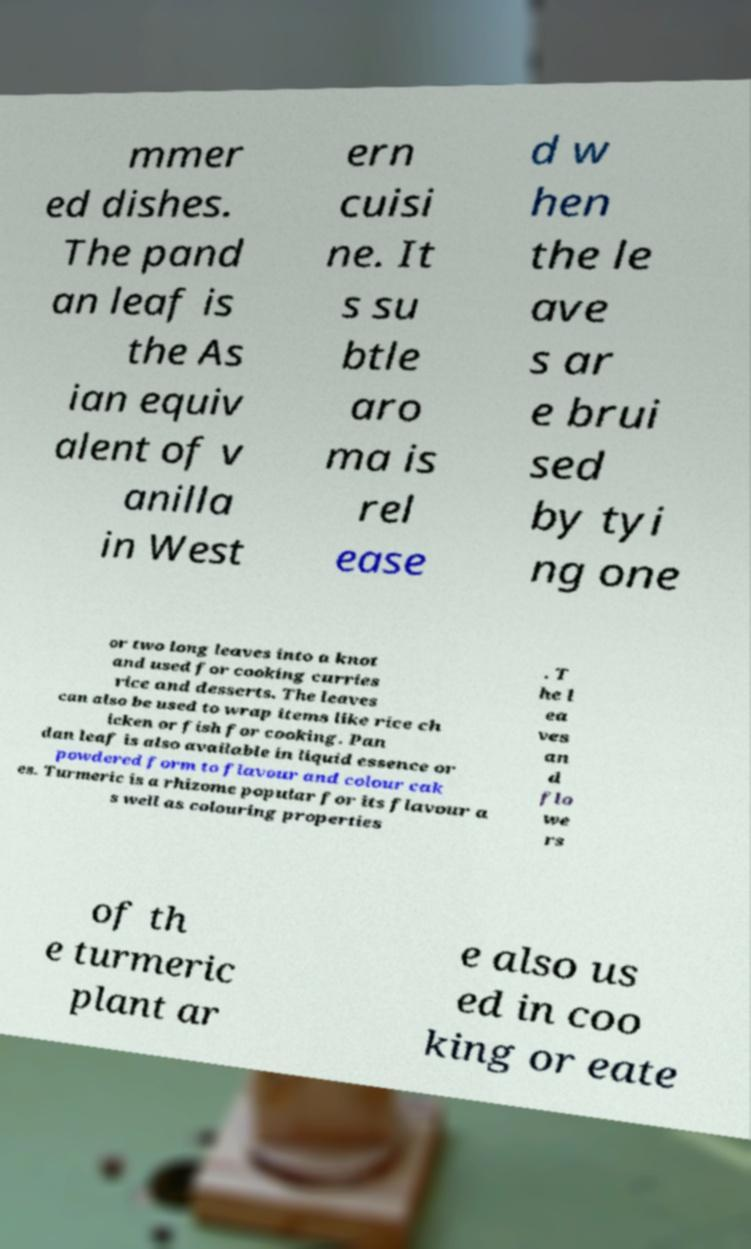Could you extract and type out the text from this image? mmer ed dishes. The pand an leaf is the As ian equiv alent of v anilla in West ern cuisi ne. It s su btle aro ma is rel ease d w hen the le ave s ar e brui sed by tyi ng one or two long leaves into a knot and used for cooking curries rice and desserts. The leaves can also be used to wrap items like rice ch icken or fish for cooking. Pan dan leaf is also available in liquid essence or powdered form to flavour and colour cak es. Turmeric is a rhizome popular for its flavour a s well as colouring properties . T he l ea ves an d flo we rs of th e turmeric plant ar e also us ed in coo king or eate 